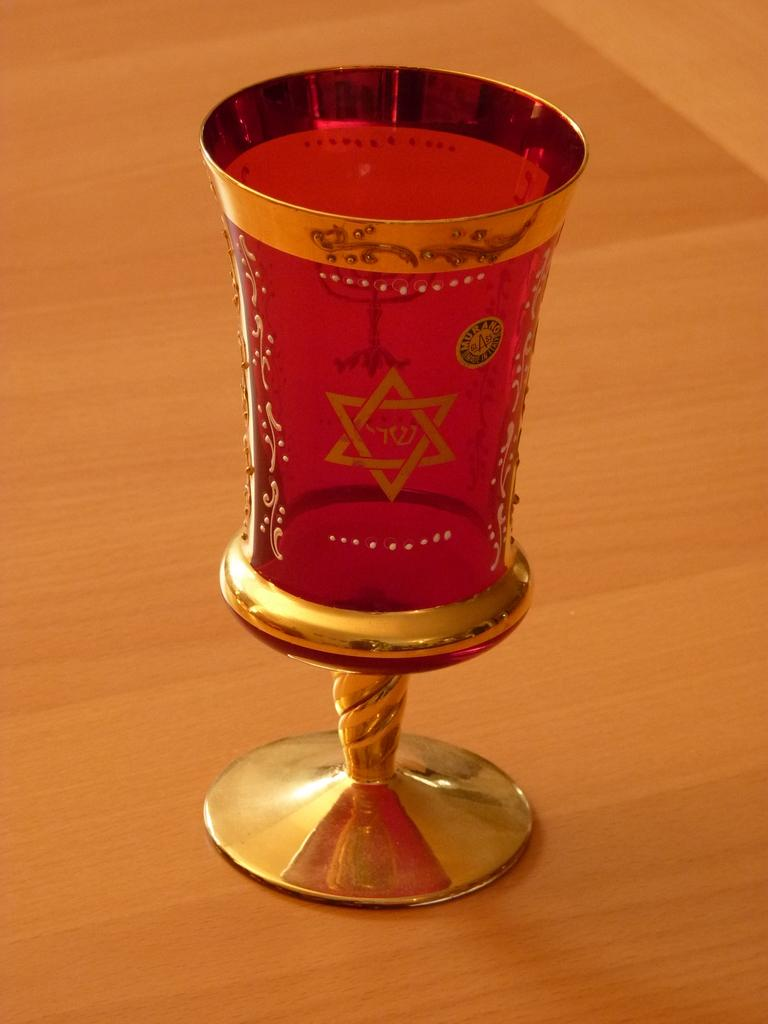What piece of furniture is present in the image? There is a table in the image. What object is placed on the table? There is a glass on the table. How many jellyfish are swimming under the table in the image? There are no jellyfish present in the image; it only features a table and a glass. 